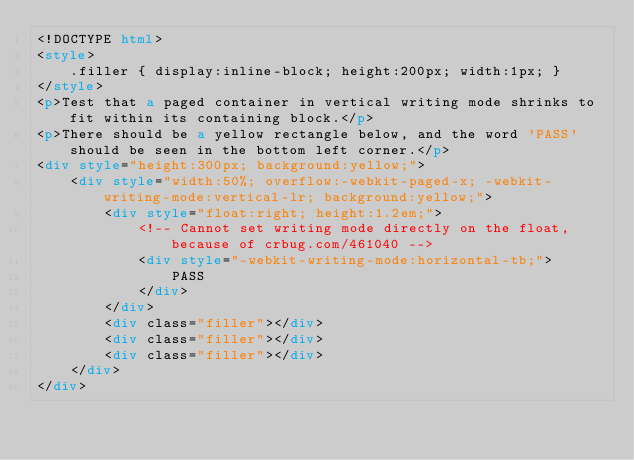Convert code to text. <code><loc_0><loc_0><loc_500><loc_500><_HTML_><!DOCTYPE html>
<style>
    .filler { display:inline-block; height:200px; width:1px; }
</style>
<p>Test that a paged container in vertical writing mode shrinks to fit within its containing block.</p>
<p>There should be a yellow rectangle below, and the word 'PASS' should be seen in the bottom left corner.</p>
<div style="height:300px; background:yellow;">
    <div style="width:50%; overflow:-webkit-paged-x; -webkit-writing-mode:vertical-lr; background:yellow;">
        <div style="float:right; height:1.2em;">
            <!-- Cannot set writing mode directly on the float, because of crbug.com/461040 -->
            <div style="-webkit-writing-mode:horizontal-tb;">
                PASS
            </div>
        </div>
        <div class="filler"></div>
        <div class="filler"></div>
        <div class="filler"></div>
    </div>
</div>
</code> 